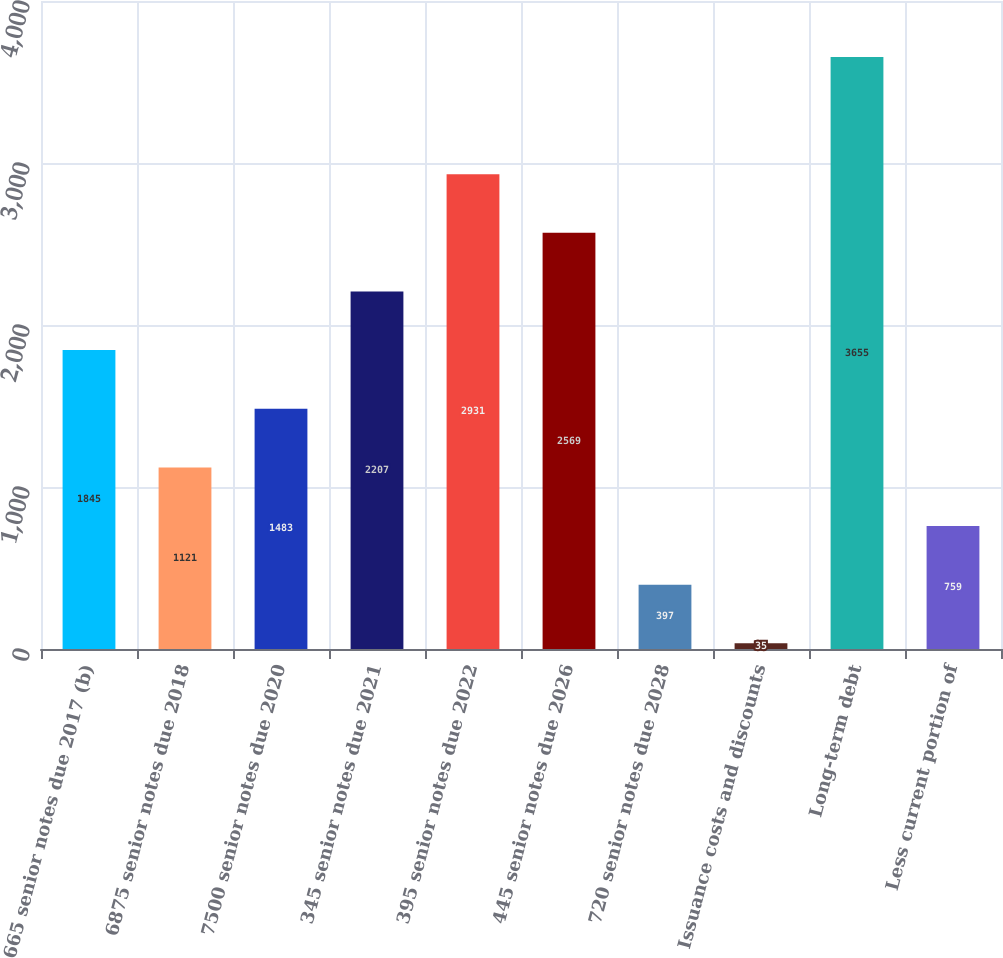Convert chart. <chart><loc_0><loc_0><loc_500><loc_500><bar_chart><fcel>665 senior notes due 2017 (b)<fcel>6875 senior notes due 2018<fcel>7500 senior notes due 2020<fcel>345 senior notes due 2021<fcel>395 senior notes due 2022<fcel>445 senior notes due 2026<fcel>720 senior notes due 2028<fcel>Issuance costs and discounts<fcel>Long-term debt<fcel>Less current portion of<nl><fcel>1845<fcel>1121<fcel>1483<fcel>2207<fcel>2931<fcel>2569<fcel>397<fcel>35<fcel>3655<fcel>759<nl></chart> 